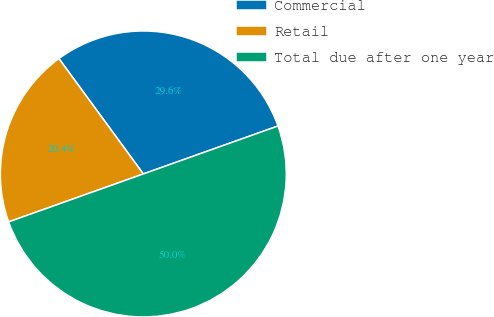Convert chart. <chart><loc_0><loc_0><loc_500><loc_500><pie_chart><fcel>Commercial<fcel>Retail<fcel>Total due after one year<nl><fcel>29.61%<fcel>20.39%<fcel>50.0%<nl></chart> 